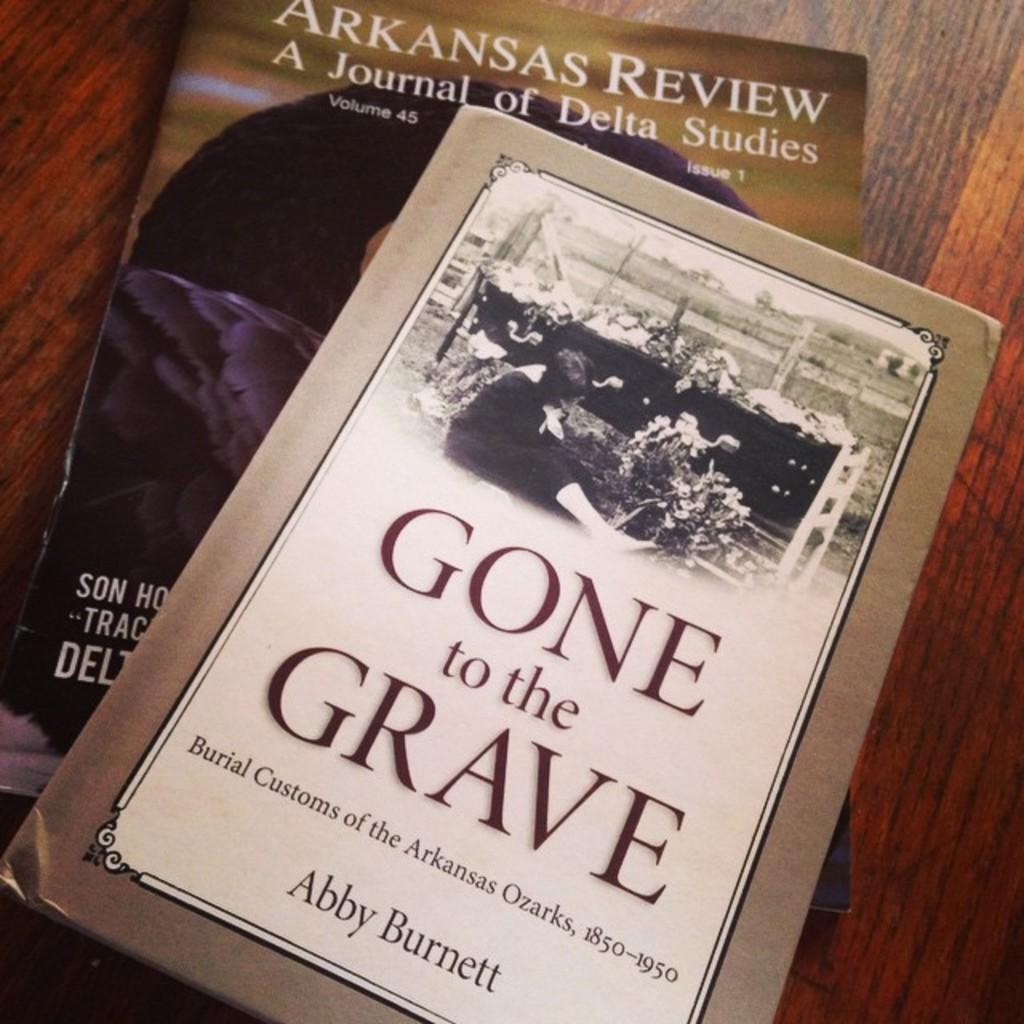<image>
Relay a brief, clear account of the picture shown. A book written by Abby Burnett is titled Gone to the Grave. 